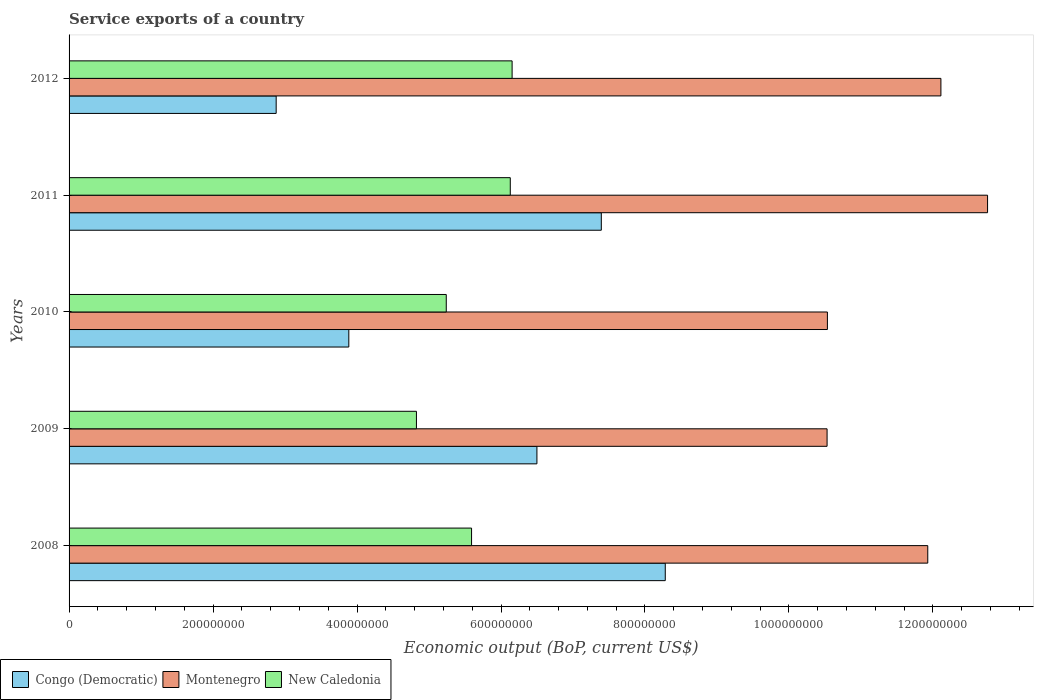How many different coloured bars are there?
Provide a short and direct response. 3. Are the number of bars per tick equal to the number of legend labels?
Your answer should be very brief. Yes. Are the number of bars on each tick of the Y-axis equal?
Your answer should be very brief. Yes. How many bars are there on the 1st tick from the top?
Ensure brevity in your answer.  3. How many bars are there on the 4th tick from the bottom?
Provide a succinct answer. 3. What is the label of the 1st group of bars from the top?
Offer a very short reply. 2012. What is the service exports in New Caledonia in 2011?
Your answer should be compact. 6.13e+08. Across all years, what is the maximum service exports in New Caledonia?
Provide a succinct answer. 6.15e+08. Across all years, what is the minimum service exports in Congo (Democratic)?
Provide a succinct answer. 2.88e+08. In which year was the service exports in New Caledonia maximum?
Provide a succinct answer. 2012. What is the total service exports in New Caledonia in the graph?
Provide a succinct answer. 2.79e+09. What is the difference between the service exports in Montenegro in 2009 and that in 2011?
Your response must be concise. -2.23e+08. What is the difference between the service exports in Congo (Democratic) in 2009 and the service exports in New Caledonia in 2008?
Offer a very short reply. 9.08e+07. What is the average service exports in Montenegro per year?
Give a very brief answer. 1.16e+09. In the year 2012, what is the difference between the service exports in Congo (Democratic) and service exports in New Caledonia?
Provide a short and direct response. -3.28e+08. In how many years, is the service exports in New Caledonia greater than 600000000 US$?
Your answer should be compact. 2. What is the ratio of the service exports in Montenegro in 2009 to that in 2011?
Your answer should be very brief. 0.83. Is the difference between the service exports in Congo (Democratic) in 2009 and 2011 greater than the difference between the service exports in New Caledonia in 2009 and 2011?
Your answer should be very brief. Yes. What is the difference between the highest and the second highest service exports in New Caledonia?
Your answer should be compact. 2.54e+06. What is the difference between the highest and the lowest service exports in Congo (Democratic)?
Your answer should be very brief. 5.41e+08. What does the 2nd bar from the top in 2009 represents?
Make the answer very short. Montenegro. What does the 3rd bar from the bottom in 2010 represents?
Provide a short and direct response. New Caledonia. Is it the case that in every year, the sum of the service exports in Congo (Democratic) and service exports in New Caledonia is greater than the service exports in Montenegro?
Make the answer very short. No. How many years are there in the graph?
Give a very brief answer. 5. Are the values on the major ticks of X-axis written in scientific E-notation?
Ensure brevity in your answer.  No. Does the graph contain any zero values?
Provide a short and direct response. No. Where does the legend appear in the graph?
Provide a short and direct response. Bottom left. How many legend labels are there?
Make the answer very short. 3. What is the title of the graph?
Make the answer very short. Service exports of a country. What is the label or title of the X-axis?
Ensure brevity in your answer.  Economic output (BoP, current US$). What is the label or title of the Y-axis?
Give a very brief answer. Years. What is the Economic output (BoP, current US$) of Congo (Democratic) in 2008?
Your response must be concise. 8.28e+08. What is the Economic output (BoP, current US$) in Montenegro in 2008?
Your answer should be compact. 1.19e+09. What is the Economic output (BoP, current US$) of New Caledonia in 2008?
Your answer should be very brief. 5.59e+08. What is the Economic output (BoP, current US$) in Congo (Democratic) in 2009?
Your response must be concise. 6.50e+08. What is the Economic output (BoP, current US$) of Montenegro in 2009?
Your answer should be very brief. 1.05e+09. What is the Economic output (BoP, current US$) in New Caledonia in 2009?
Provide a short and direct response. 4.83e+08. What is the Economic output (BoP, current US$) in Congo (Democratic) in 2010?
Your response must be concise. 3.89e+08. What is the Economic output (BoP, current US$) of Montenegro in 2010?
Make the answer very short. 1.05e+09. What is the Economic output (BoP, current US$) of New Caledonia in 2010?
Your answer should be compact. 5.24e+08. What is the Economic output (BoP, current US$) of Congo (Democratic) in 2011?
Ensure brevity in your answer.  7.39e+08. What is the Economic output (BoP, current US$) of Montenegro in 2011?
Provide a succinct answer. 1.28e+09. What is the Economic output (BoP, current US$) of New Caledonia in 2011?
Provide a short and direct response. 6.13e+08. What is the Economic output (BoP, current US$) of Congo (Democratic) in 2012?
Offer a terse response. 2.88e+08. What is the Economic output (BoP, current US$) in Montenegro in 2012?
Give a very brief answer. 1.21e+09. What is the Economic output (BoP, current US$) of New Caledonia in 2012?
Your answer should be very brief. 6.15e+08. Across all years, what is the maximum Economic output (BoP, current US$) of Congo (Democratic)?
Offer a terse response. 8.28e+08. Across all years, what is the maximum Economic output (BoP, current US$) in Montenegro?
Provide a succinct answer. 1.28e+09. Across all years, what is the maximum Economic output (BoP, current US$) of New Caledonia?
Give a very brief answer. 6.15e+08. Across all years, what is the minimum Economic output (BoP, current US$) of Congo (Democratic)?
Offer a terse response. 2.88e+08. Across all years, what is the minimum Economic output (BoP, current US$) of Montenegro?
Keep it short and to the point. 1.05e+09. Across all years, what is the minimum Economic output (BoP, current US$) of New Caledonia?
Your response must be concise. 4.83e+08. What is the total Economic output (BoP, current US$) of Congo (Democratic) in the graph?
Your response must be concise. 2.89e+09. What is the total Economic output (BoP, current US$) of Montenegro in the graph?
Keep it short and to the point. 5.79e+09. What is the total Economic output (BoP, current US$) of New Caledonia in the graph?
Keep it short and to the point. 2.79e+09. What is the difference between the Economic output (BoP, current US$) in Congo (Democratic) in 2008 and that in 2009?
Ensure brevity in your answer.  1.78e+08. What is the difference between the Economic output (BoP, current US$) in Montenegro in 2008 and that in 2009?
Make the answer very short. 1.40e+08. What is the difference between the Economic output (BoP, current US$) in New Caledonia in 2008 and that in 2009?
Ensure brevity in your answer.  7.66e+07. What is the difference between the Economic output (BoP, current US$) in Congo (Democratic) in 2008 and that in 2010?
Provide a succinct answer. 4.40e+08. What is the difference between the Economic output (BoP, current US$) in Montenegro in 2008 and that in 2010?
Provide a short and direct response. 1.39e+08. What is the difference between the Economic output (BoP, current US$) of New Caledonia in 2008 and that in 2010?
Your answer should be very brief. 3.52e+07. What is the difference between the Economic output (BoP, current US$) of Congo (Democratic) in 2008 and that in 2011?
Your response must be concise. 8.88e+07. What is the difference between the Economic output (BoP, current US$) of Montenegro in 2008 and that in 2011?
Keep it short and to the point. -8.31e+07. What is the difference between the Economic output (BoP, current US$) in New Caledonia in 2008 and that in 2011?
Your answer should be very brief. -5.38e+07. What is the difference between the Economic output (BoP, current US$) of Congo (Democratic) in 2008 and that in 2012?
Offer a terse response. 5.41e+08. What is the difference between the Economic output (BoP, current US$) of Montenegro in 2008 and that in 2012?
Your answer should be compact. -1.83e+07. What is the difference between the Economic output (BoP, current US$) in New Caledonia in 2008 and that in 2012?
Keep it short and to the point. -5.63e+07. What is the difference between the Economic output (BoP, current US$) in Congo (Democratic) in 2009 and that in 2010?
Ensure brevity in your answer.  2.61e+08. What is the difference between the Economic output (BoP, current US$) in Montenegro in 2009 and that in 2010?
Your answer should be compact. -4.45e+05. What is the difference between the Economic output (BoP, current US$) of New Caledonia in 2009 and that in 2010?
Provide a succinct answer. -4.14e+07. What is the difference between the Economic output (BoP, current US$) of Congo (Democratic) in 2009 and that in 2011?
Ensure brevity in your answer.  -8.95e+07. What is the difference between the Economic output (BoP, current US$) of Montenegro in 2009 and that in 2011?
Keep it short and to the point. -2.23e+08. What is the difference between the Economic output (BoP, current US$) of New Caledonia in 2009 and that in 2011?
Provide a short and direct response. -1.30e+08. What is the difference between the Economic output (BoP, current US$) in Congo (Democratic) in 2009 and that in 2012?
Your response must be concise. 3.62e+08. What is the difference between the Economic output (BoP, current US$) of Montenegro in 2009 and that in 2012?
Your answer should be compact. -1.58e+08. What is the difference between the Economic output (BoP, current US$) of New Caledonia in 2009 and that in 2012?
Your answer should be very brief. -1.33e+08. What is the difference between the Economic output (BoP, current US$) of Congo (Democratic) in 2010 and that in 2011?
Your answer should be compact. -3.51e+08. What is the difference between the Economic output (BoP, current US$) in Montenegro in 2010 and that in 2011?
Offer a terse response. -2.22e+08. What is the difference between the Economic output (BoP, current US$) in New Caledonia in 2010 and that in 2011?
Make the answer very short. -8.89e+07. What is the difference between the Economic output (BoP, current US$) in Congo (Democratic) in 2010 and that in 2012?
Provide a short and direct response. 1.01e+08. What is the difference between the Economic output (BoP, current US$) in Montenegro in 2010 and that in 2012?
Make the answer very short. -1.58e+08. What is the difference between the Economic output (BoP, current US$) in New Caledonia in 2010 and that in 2012?
Provide a short and direct response. -9.15e+07. What is the difference between the Economic output (BoP, current US$) of Congo (Democratic) in 2011 and that in 2012?
Provide a short and direct response. 4.52e+08. What is the difference between the Economic output (BoP, current US$) in Montenegro in 2011 and that in 2012?
Provide a short and direct response. 6.48e+07. What is the difference between the Economic output (BoP, current US$) of New Caledonia in 2011 and that in 2012?
Provide a succinct answer. -2.54e+06. What is the difference between the Economic output (BoP, current US$) of Congo (Democratic) in 2008 and the Economic output (BoP, current US$) of Montenegro in 2009?
Make the answer very short. -2.25e+08. What is the difference between the Economic output (BoP, current US$) in Congo (Democratic) in 2008 and the Economic output (BoP, current US$) in New Caledonia in 2009?
Give a very brief answer. 3.46e+08. What is the difference between the Economic output (BoP, current US$) in Montenegro in 2008 and the Economic output (BoP, current US$) in New Caledonia in 2009?
Make the answer very short. 7.10e+08. What is the difference between the Economic output (BoP, current US$) of Congo (Democratic) in 2008 and the Economic output (BoP, current US$) of Montenegro in 2010?
Offer a terse response. -2.25e+08. What is the difference between the Economic output (BoP, current US$) of Congo (Democratic) in 2008 and the Economic output (BoP, current US$) of New Caledonia in 2010?
Your response must be concise. 3.04e+08. What is the difference between the Economic output (BoP, current US$) in Montenegro in 2008 and the Economic output (BoP, current US$) in New Caledonia in 2010?
Provide a short and direct response. 6.69e+08. What is the difference between the Economic output (BoP, current US$) in Congo (Democratic) in 2008 and the Economic output (BoP, current US$) in Montenegro in 2011?
Ensure brevity in your answer.  -4.48e+08. What is the difference between the Economic output (BoP, current US$) of Congo (Democratic) in 2008 and the Economic output (BoP, current US$) of New Caledonia in 2011?
Give a very brief answer. 2.15e+08. What is the difference between the Economic output (BoP, current US$) of Montenegro in 2008 and the Economic output (BoP, current US$) of New Caledonia in 2011?
Offer a terse response. 5.80e+08. What is the difference between the Economic output (BoP, current US$) of Congo (Democratic) in 2008 and the Economic output (BoP, current US$) of Montenegro in 2012?
Keep it short and to the point. -3.83e+08. What is the difference between the Economic output (BoP, current US$) of Congo (Democratic) in 2008 and the Economic output (BoP, current US$) of New Caledonia in 2012?
Your response must be concise. 2.13e+08. What is the difference between the Economic output (BoP, current US$) of Montenegro in 2008 and the Economic output (BoP, current US$) of New Caledonia in 2012?
Provide a short and direct response. 5.77e+08. What is the difference between the Economic output (BoP, current US$) of Congo (Democratic) in 2009 and the Economic output (BoP, current US$) of Montenegro in 2010?
Your response must be concise. -4.04e+08. What is the difference between the Economic output (BoP, current US$) in Congo (Democratic) in 2009 and the Economic output (BoP, current US$) in New Caledonia in 2010?
Provide a short and direct response. 1.26e+08. What is the difference between the Economic output (BoP, current US$) of Montenegro in 2009 and the Economic output (BoP, current US$) of New Caledonia in 2010?
Keep it short and to the point. 5.29e+08. What is the difference between the Economic output (BoP, current US$) in Congo (Democratic) in 2009 and the Economic output (BoP, current US$) in Montenegro in 2011?
Keep it short and to the point. -6.26e+08. What is the difference between the Economic output (BoP, current US$) in Congo (Democratic) in 2009 and the Economic output (BoP, current US$) in New Caledonia in 2011?
Provide a succinct answer. 3.70e+07. What is the difference between the Economic output (BoP, current US$) of Montenegro in 2009 and the Economic output (BoP, current US$) of New Caledonia in 2011?
Your response must be concise. 4.40e+08. What is the difference between the Economic output (BoP, current US$) of Congo (Democratic) in 2009 and the Economic output (BoP, current US$) of Montenegro in 2012?
Your answer should be compact. -5.61e+08. What is the difference between the Economic output (BoP, current US$) in Congo (Democratic) in 2009 and the Economic output (BoP, current US$) in New Caledonia in 2012?
Provide a short and direct response. 3.45e+07. What is the difference between the Economic output (BoP, current US$) of Montenegro in 2009 and the Economic output (BoP, current US$) of New Caledonia in 2012?
Provide a short and direct response. 4.38e+08. What is the difference between the Economic output (BoP, current US$) in Congo (Democratic) in 2010 and the Economic output (BoP, current US$) in Montenegro in 2011?
Give a very brief answer. -8.87e+08. What is the difference between the Economic output (BoP, current US$) of Congo (Democratic) in 2010 and the Economic output (BoP, current US$) of New Caledonia in 2011?
Provide a short and direct response. -2.24e+08. What is the difference between the Economic output (BoP, current US$) in Montenegro in 2010 and the Economic output (BoP, current US$) in New Caledonia in 2011?
Offer a terse response. 4.41e+08. What is the difference between the Economic output (BoP, current US$) in Congo (Democratic) in 2010 and the Economic output (BoP, current US$) in Montenegro in 2012?
Your answer should be very brief. -8.22e+08. What is the difference between the Economic output (BoP, current US$) in Congo (Democratic) in 2010 and the Economic output (BoP, current US$) in New Caledonia in 2012?
Provide a short and direct response. -2.27e+08. What is the difference between the Economic output (BoP, current US$) of Montenegro in 2010 and the Economic output (BoP, current US$) of New Caledonia in 2012?
Offer a terse response. 4.38e+08. What is the difference between the Economic output (BoP, current US$) in Congo (Democratic) in 2011 and the Economic output (BoP, current US$) in Montenegro in 2012?
Make the answer very short. -4.72e+08. What is the difference between the Economic output (BoP, current US$) of Congo (Democratic) in 2011 and the Economic output (BoP, current US$) of New Caledonia in 2012?
Provide a succinct answer. 1.24e+08. What is the difference between the Economic output (BoP, current US$) of Montenegro in 2011 and the Economic output (BoP, current US$) of New Caledonia in 2012?
Provide a short and direct response. 6.60e+08. What is the average Economic output (BoP, current US$) in Congo (Democratic) per year?
Provide a succinct answer. 5.79e+08. What is the average Economic output (BoP, current US$) in Montenegro per year?
Provide a short and direct response. 1.16e+09. What is the average Economic output (BoP, current US$) of New Caledonia per year?
Give a very brief answer. 5.59e+08. In the year 2008, what is the difference between the Economic output (BoP, current US$) of Congo (Democratic) and Economic output (BoP, current US$) of Montenegro?
Offer a very short reply. -3.65e+08. In the year 2008, what is the difference between the Economic output (BoP, current US$) of Congo (Democratic) and Economic output (BoP, current US$) of New Caledonia?
Provide a succinct answer. 2.69e+08. In the year 2008, what is the difference between the Economic output (BoP, current US$) in Montenegro and Economic output (BoP, current US$) in New Caledonia?
Provide a short and direct response. 6.34e+08. In the year 2009, what is the difference between the Economic output (BoP, current US$) of Congo (Democratic) and Economic output (BoP, current US$) of Montenegro?
Provide a short and direct response. -4.03e+08. In the year 2009, what is the difference between the Economic output (BoP, current US$) of Congo (Democratic) and Economic output (BoP, current US$) of New Caledonia?
Provide a short and direct response. 1.67e+08. In the year 2009, what is the difference between the Economic output (BoP, current US$) of Montenegro and Economic output (BoP, current US$) of New Caledonia?
Your response must be concise. 5.70e+08. In the year 2010, what is the difference between the Economic output (BoP, current US$) in Congo (Democratic) and Economic output (BoP, current US$) in Montenegro?
Offer a very short reply. -6.65e+08. In the year 2010, what is the difference between the Economic output (BoP, current US$) of Congo (Democratic) and Economic output (BoP, current US$) of New Caledonia?
Provide a succinct answer. -1.35e+08. In the year 2010, what is the difference between the Economic output (BoP, current US$) in Montenegro and Economic output (BoP, current US$) in New Caledonia?
Provide a succinct answer. 5.29e+08. In the year 2011, what is the difference between the Economic output (BoP, current US$) of Congo (Democratic) and Economic output (BoP, current US$) of Montenegro?
Give a very brief answer. -5.37e+08. In the year 2011, what is the difference between the Economic output (BoP, current US$) in Congo (Democratic) and Economic output (BoP, current US$) in New Caledonia?
Keep it short and to the point. 1.26e+08. In the year 2011, what is the difference between the Economic output (BoP, current US$) of Montenegro and Economic output (BoP, current US$) of New Caledonia?
Keep it short and to the point. 6.63e+08. In the year 2012, what is the difference between the Economic output (BoP, current US$) in Congo (Democratic) and Economic output (BoP, current US$) in Montenegro?
Ensure brevity in your answer.  -9.23e+08. In the year 2012, what is the difference between the Economic output (BoP, current US$) in Congo (Democratic) and Economic output (BoP, current US$) in New Caledonia?
Provide a short and direct response. -3.28e+08. In the year 2012, what is the difference between the Economic output (BoP, current US$) in Montenegro and Economic output (BoP, current US$) in New Caledonia?
Your response must be concise. 5.96e+08. What is the ratio of the Economic output (BoP, current US$) in Congo (Democratic) in 2008 to that in 2009?
Provide a succinct answer. 1.27. What is the ratio of the Economic output (BoP, current US$) of Montenegro in 2008 to that in 2009?
Make the answer very short. 1.13. What is the ratio of the Economic output (BoP, current US$) in New Caledonia in 2008 to that in 2009?
Provide a succinct answer. 1.16. What is the ratio of the Economic output (BoP, current US$) in Congo (Democratic) in 2008 to that in 2010?
Offer a very short reply. 2.13. What is the ratio of the Economic output (BoP, current US$) in Montenegro in 2008 to that in 2010?
Your answer should be compact. 1.13. What is the ratio of the Economic output (BoP, current US$) in New Caledonia in 2008 to that in 2010?
Provide a short and direct response. 1.07. What is the ratio of the Economic output (BoP, current US$) in Congo (Democratic) in 2008 to that in 2011?
Offer a terse response. 1.12. What is the ratio of the Economic output (BoP, current US$) of Montenegro in 2008 to that in 2011?
Ensure brevity in your answer.  0.93. What is the ratio of the Economic output (BoP, current US$) in New Caledonia in 2008 to that in 2011?
Give a very brief answer. 0.91. What is the ratio of the Economic output (BoP, current US$) in Congo (Democratic) in 2008 to that in 2012?
Offer a terse response. 2.88. What is the ratio of the Economic output (BoP, current US$) in Montenegro in 2008 to that in 2012?
Your answer should be very brief. 0.98. What is the ratio of the Economic output (BoP, current US$) of New Caledonia in 2008 to that in 2012?
Your answer should be compact. 0.91. What is the ratio of the Economic output (BoP, current US$) of Congo (Democratic) in 2009 to that in 2010?
Offer a terse response. 1.67. What is the ratio of the Economic output (BoP, current US$) in New Caledonia in 2009 to that in 2010?
Provide a succinct answer. 0.92. What is the ratio of the Economic output (BoP, current US$) of Congo (Democratic) in 2009 to that in 2011?
Provide a short and direct response. 0.88. What is the ratio of the Economic output (BoP, current US$) of Montenegro in 2009 to that in 2011?
Offer a very short reply. 0.83. What is the ratio of the Economic output (BoP, current US$) in New Caledonia in 2009 to that in 2011?
Offer a terse response. 0.79. What is the ratio of the Economic output (BoP, current US$) in Congo (Democratic) in 2009 to that in 2012?
Offer a very short reply. 2.26. What is the ratio of the Economic output (BoP, current US$) in Montenegro in 2009 to that in 2012?
Provide a succinct answer. 0.87. What is the ratio of the Economic output (BoP, current US$) of New Caledonia in 2009 to that in 2012?
Make the answer very short. 0.78. What is the ratio of the Economic output (BoP, current US$) of Congo (Democratic) in 2010 to that in 2011?
Make the answer very short. 0.53. What is the ratio of the Economic output (BoP, current US$) in Montenegro in 2010 to that in 2011?
Ensure brevity in your answer.  0.83. What is the ratio of the Economic output (BoP, current US$) in New Caledonia in 2010 to that in 2011?
Make the answer very short. 0.85. What is the ratio of the Economic output (BoP, current US$) in Congo (Democratic) in 2010 to that in 2012?
Make the answer very short. 1.35. What is the ratio of the Economic output (BoP, current US$) of Montenegro in 2010 to that in 2012?
Your answer should be compact. 0.87. What is the ratio of the Economic output (BoP, current US$) of New Caledonia in 2010 to that in 2012?
Offer a terse response. 0.85. What is the ratio of the Economic output (BoP, current US$) in Congo (Democratic) in 2011 to that in 2012?
Offer a very short reply. 2.57. What is the ratio of the Economic output (BoP, current US$) of Montenegro in 2011 to that in 2012?
Offer a terse response. 1.05. What is the difference between the highest and the second highest Economic output (BoP, current US$) of Congo (Democratic)?
Your response must be concise. 8.88e+07. What is the difference between the highest and the second highest Economic output (BoP, current US$) of Montenegro?
Make the answer very short. 6.48e+07. What is the difference between the highest and the second highest Economic output (BoP, current US$) of New Caledonia?
Keep it short and to the point. 2.54e+06. What is the difference between the highest and the lowest Economic output (BoP, current US$) of Congo (Democratic)?
Offer a terse response. 5.41e+08. What is the difference between the highest and the lowest Economic output (BoP, current US$) in Montenegro?
Ensure brevity in your answer.  2.23e+08. What is the difference between the highest and the lowest Economic output (BoP, current US$) in New Caledonia?
Your answer should be compact. 1.33e+08. 